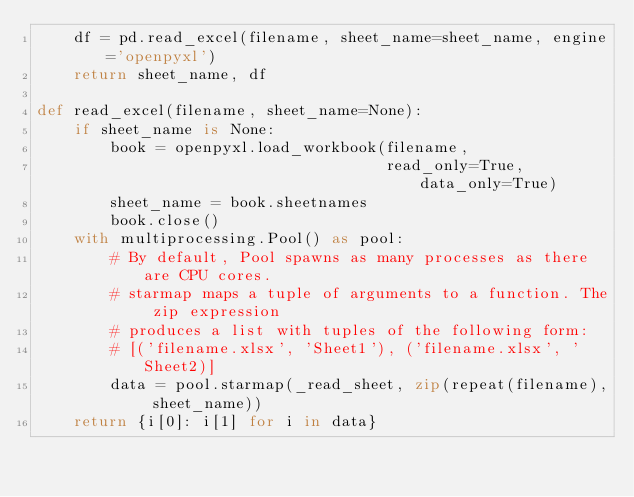<code> <loc_0><loc_0><loc_500><loc_500><_Python_>    df = pd.read_excel(filename, sheet_name=sheet_name, engine='openpyxl')
    return sheet_name, df

def read_excel(filename, sheet_name=None):
    if sheet_name is None:
        book = openpyxl.load_workbook(filename,
                                      read_only=True, data_only=True)
        sheet_name = book.sheetnames
        book.close()
    with multiprocessing.Pool() as pool:
        # By default, Pool spawns as many processes as there are CPU cores.
        # starmap maps a tuple of arguments to a function. The zip expression
        # produces a list with tuples of the following form:
        # [('filename.xlsx', 'Sheet1'), ('filename.xlsx', 'Sheet2)]
        data = pool.starmap(_read_sheet, zip(repeat(filename), sheet_name))
    return {i[0]: i[1] for i in data}
</code> 